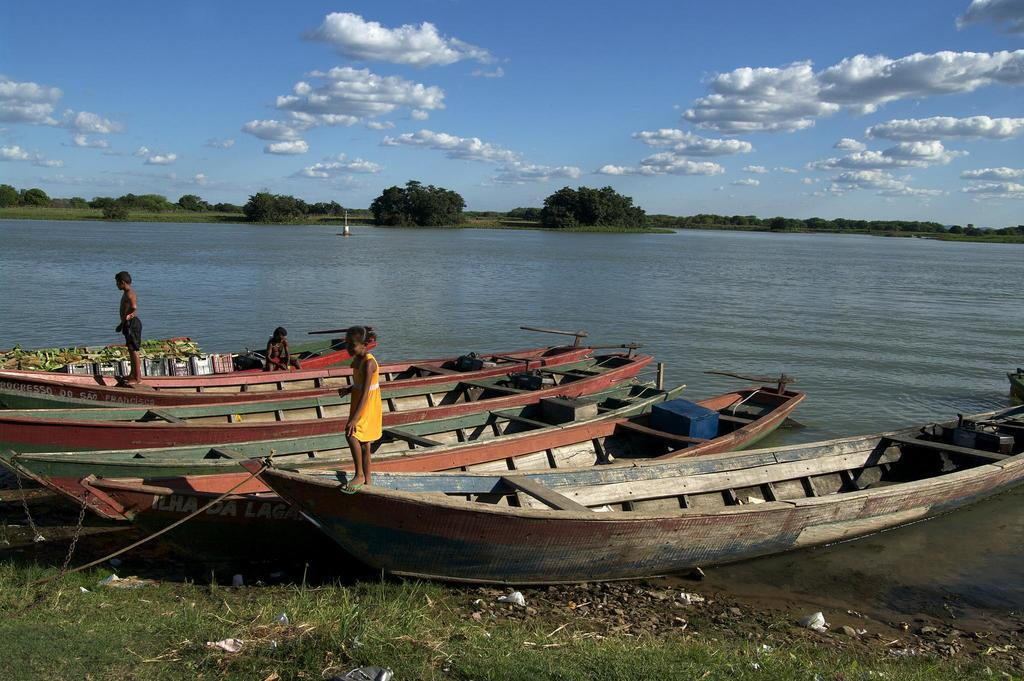What is on the water in the image? There are boats on the water in the image. Are there any people on the boats? Yes, there are people on the boats. What can be seen in the background of the image? There are trees and the sky visible in the background of the image. What type of vegetation is present in the image? There is grass in the image. What type of agreement is being discussed by the woman in the image? There is no woman present in the image; it features boats on the water with people on them. What color is the scarf worn by the person on the boat? There is no mention of a scarf in the image, as it only features boats, people, trees, sky, and grass. 